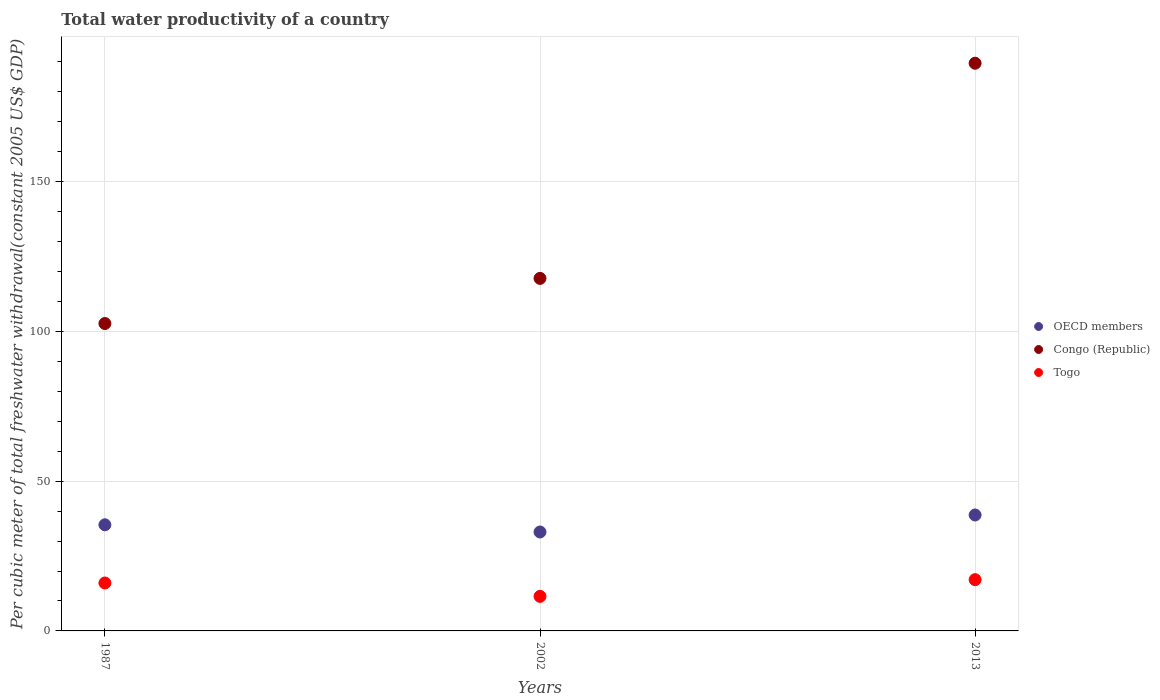What is the total water productivity in OECD members in 2002?
Provide a succinct answer. 33.04. Across all years, what is the maximum total water productivity in Togo?
Your answer should be compact. 17.12. Across all years, what is the minimum total water productivity in Congo (Republic)?
Make the answer very short. 102.65. In which year was the total water productivity in OECD members minimum?
Offer a terse response. 2002. What is the total total water productivity in OECD members in the graph?
Provide a short and direct response. 107.19. What is the difference between the total water productivity in Congo (Republic) in 1987 and that in 2002?
Make the answer very short. -15.07. What is the difference between the total water productivity in Togo in 2002 and the total water productivity in OECD members in 2013?
Your answer should be compact. -27.17. What is the average total water productivity in Congo (Republic) per year?
Your answer should be compact. 136.64. In the year 2013, what is the difference between the total water productivity in Congo (Republic) and total water productivity in OECD members?
Your answer should be compact. 150.85. In how many years, is the total water productivity in OECD members greater than 180 US$?
Provide a short and direct response. 0. What is the ratio of the total water productivity in OECD members in 2002 to that in 2013?
Make the answer very short. 0.85. Is the total water productivity in Togo in 1987 less than that in 2002?
Make the answer very short. No. What is the difference between the highest and the second highest total water productivity in OECD members?
Ensure brevity in your answer.  3.27. What is the difference between the highest and the lowest total water productivity in OECD members?
Your answer should be very brief. 5.68. In how many years, is the total water productivity in Congo (Republic) greater than the average total water productivity in Congo (Republic) taken over all years?
Ensure brevity in your answer.  1. Is the total water productivity in Togo strictly less than the total water productivity in Congo (Republic) over the years?
Ensure brevity in your answer.  Yes. How many dotlines are there?
Your answer should be very brief. 3. How many years are there in the graph?
Your answer should be very brief. 3. Are the values on the major ticks of Y-axis written in scientific E-notation?
Your answer should be very brief. No. Does the graph contain any zero values?
Your answer should be compact. No. Where does the legend appear in the graph?
Offer a terse response. Center right. How many legend labels are there?
Offer a terse response. 3. How are the legend labels stacked?
Offer a terse response. Vertical. What is the title of the graph?
Offer a very short reply. Total water productivity of a country. What is the label or title of the Y-axis?
Provide a short and direct response. Per cubic meter of total freshwater withdrawal(constant 2005 US$ GDP). What is the Per cubic meter of total freshwater withdrawal(constant 2005 US$ GDP) of OECD members in 1987?
Provide a short and direct response. 35.44. What is the Per cubic meter of total freshwater withdrawal(constant 2005 US$ GDP) of Congo (Republic) in 1987?
Your response must be concise. 102.65. What is the Per cubic meter of total freshwater withdrawal(constant 2005 US$ GDP) in Togo in 1987?
Your response must be concise. 16. What is the Per cubic meter of total freshwater withdrawal(constant 2005 US$ GDP) in OECD members in 2002?
Keep it short and to the point. 33.04. What is the Per cubic meter of total freshwater withdrawal(constant 2005 US$ GDP) of Congo (Republic) in 2002?
Provide a short and direct response. 117.72. What is the Per cubic meter of total freshwater withdrawal(constant 2005 US$ GDP) in Togo in 2002?
Provide a succinct answer. 11.54. What is the Per cubic meter of total freshwater withdrawal(constant 2005 US$ GDP) of OECD members in 2013?
Keep it short and to the point. 38.71. What is the Per cubic meter of total freshwater withdrawal(constant 2005 US$ GDP) in Congo (Republic) in 2013?
Your answer should be very brief. 189.56. What is the Per cubic meter of total freshwater withdrawal(constant 2005 US$ GDP) of Togo in 2013?
Provide a short and direct response. 17.12. Across all years, what is the maximum Per cubic meter of total freshwater withdrawal(constant 2005 US$ GDP) of OECD members?
Keep it short and to the point. 38.71. Across all years, what is the maximum Per cubic meter of total freshwater withdrawal(constant 2005 US$ GDP) of Congo (Republic)?
Your answer should be compact. 189.56. Across all years, what is the maximum Per cubic meter of total freshwater withdrawal(constant 2005 US$ GDP) of Togo?
Give a very brief answer. 17.12. Across all years, what is the minimum Per cubic meter of total freshwater withdrawal(constant 2005 US$ GDP) in OECD members?
Provide a succinct answer. 33.04. Across all years, what is the minimum Per cubic meter of total freshwater withdrawal(constant 2005 US$ GDP) in Congo (Republic)?
Offer a very short reply. 102.65. Across all years, what is the minimum Per cubic meter of total freshwater withdrawal(constant 2005 US$ GDP) of Togo?
Your answer should be compact. 11.54. What is the total Per cubic meter of total freshwater withdrawal(constant 2005 US$ GDP) of OECD members in the graph?
Offer a terse response. 107.19. What is the total Per cubic meter of total freshwater withdrawal(constant 2005 US$ GDP) of Congo (Republic) in the graph?
Give a very brief answer. 409.93. What is the total Per cubic meter of total freshwater withdrawal(constant 2005 US$ GDP) in Togo in the graph?
Your answer should be very brief. 44.66. What is the difference between the Per cubic meter of total freshwater withdrawal(constant 2005 US$ GDP) of OECD members in 1987 and that in 2002?
Offer a terse response. 2.4. What is the difference between the Per cubic meter of total freshwater withdrawal(constant 2005 US$ GDP) in Congo (Republic) in 1987 and that in 2002?
Give a very brief answer. -15.07. What is the difference between the Per cubic meter of total freshwater withdrawal(constant 2005 US$ GDP) in Togo in 1987 and that in 2002?
Provide a succinct answer. 4.46. What is the difference between the Per cubic meter of total freshwater withdrawal(constant 2005 US$ GDP) in OECD members in 1987 and that in 2013?
Your response must be concise. -3.27. What is the difference between the Per cubic meter of total freshwater withdrawal(constant 2005 US$ GDP) in Congo (Republic) in 1987 and that in 2013?
Keep it short and to the point. -86.91. What is the difference between the Per cubic meter of total freshwater withdrawal(constant 2005 US$ GDP) of Togo in 1987 and that in 2013?
Provide a short and direct response. -1.11. What is the difference between the Per cubic meter of total freshwater withdrawal(constant 2005 US$ GDP) of OECD members in 2002 and that in 2013?
Ensure brevity in your answer.  -5.68. What is the difference between the Per cubic meter of total freshwater withdrawal(constant 2005 US$ GDP) of Congo (Republic) in 2002 and that in 2013?
Give a very brief answer. -71.85. What is the difference between the Per cubic meter of total freshwater withdrawal(constant 2005 US$ GDP) of Togo in 2002 and that in 2013?
Your answer should be compact. -5.58. What is the difference between the Per cubic meter of total freshwater withdrawal(constant 2005 US$ GDP) of OECD members in 1987 and the Per cubic meter of total freshwater withdrawal(constant 2005 US$ GDP) of Congo (Republic) in 2002?
Make the answer very short. -82.28. What is the difference between the Per cubic meter of total freshwater withdrawal(constant 2005 US$ GDP) of OECD members in 1987 and the Per cubic meter of total freshwater withdrawal(constant 2005 US$ GDP) of Togo in 2002?
Your answer should be compact. 23.9. What is the difference between the Per cubic meter of total freshwater withdrawal(constant 2005 US$ GDP) in Congo (Republic) in 1987 and the Per cubic meter of total freshwater withdrawal(constant 2005 US$ GDP) in Togo in 2002?
Make the answer very short. 91.11. What is the difference between the Per cubic meter of total freshwater withdrawal(constant 2005 US$ GDP) in OECD members in 1987 and the Per cubic meter of total freshwater withdrawal(constant 2005 US$ GDP) in Congo (Republic) in 2013?
Give a very brief answer. -154.12. What is the difference between the Per cubic meter of total freshwater withdrawal(constant 2005 US$ GDP) in OECD members in 1987 and the Per cubic meter of total freshwater withdrawal(constant 2005 US$ GDP) in Togo in 2013?
Your answer should be very brief. 18.32. What is the difference between the Per cubic meter of total freshwater withdrawal(constant 2005 US$ GDP) in Congo (Republic) in 1987 and the Per cubic meter of total freshwater withdrawal(constant 2005 US$ GDP) in Togo in 2013?
Your answer should be very brief. 85.53. What is the difference between the Per cubic meter of total freshwater withdrawal(constant 2005 US$ GDP) in OECD members in 2002 and the Per cubic meter of total freshwater withdrawal(constant 2005 US$ GDP) in Congo (Republic) in 2013?
Offer a very short reply. -156.53. What is the difference between the Per cubic meter of total freshwater withdrawal(constant 2005 US$ GDP) in OECD members in 2002 and the Per cubic meter of total freshwater withdrawal(constant 2005 US$ GDP) in Togo in 2013?
Make the answer very short. 15.92. What is the difference between the Per cubic meter of total freshwater withdrawal(constant 2005 US$ GDP) in Congo (Republic) in 2002 and the Per cubic meter of total freshwater withdrawal(constant 2005 US$ GDP) in Togo in 2013?
Keep it short and to the point. 100.6. What is the average Per cubic meter of total freshwater withdrawal(constant 2005 US$ GDP) of OECD members per year?
Provide a succinct answer. 35.73. What is the average Per cubic meter of total freshwater withdrawal(constant 2005 US$ GDP) of Congo (Republic) per year?
Your answer should be compact. 136.64. What is the average Per cubic meter of total freshwater withdrawal(constant 2005 US$ GDP) of Togo per year?
Give a very brief answer. 14.89. In the year 1987, what is the difference between the Per cubic meter of total freshwater withdrawal(constant 2005 US$ GDP) of OECD members and Per cubic meter of total freshwater withdrawal(constant 2005 US$ GDP) of Congo (Republic)?
Your response must be concise. -67.21. In the year 1987, what is the difference between the Per cubic meter of total freshwater withdrawal(constant 2005 US$ GDP) in OECD members and Per cubic meter of total freshwater withdrawal(constant 2005 US$ GDP) in Togo?
Keep it short and to the point. 19.44. In the year 1987, what is the difference between the Per cubic meter of total freshwater withdrawal(constant 2005 US$ GDP) in Congo (Republic) and Per cubic meter of total freshwater withdrawal(constant 2005 US$ GDP) in Togo?
Keep it short and to the point. 86.65. In the year 2002, what is the difference between the Per cubic meter of total freshwater withdrawal(constant 2005 US$ GDP) in OECD members and Per cubic meter of total freshwater withdrawal(constant 2005 US$ GDP) in Congo (Republic)?
Give a very brief answer. -84.68. In the year 2002, what is the difference between the Per cubic meter of total freshwater withdrawal(constant 2005 US$ GDP) of OECD members and Per cubic meter of total freshwater withdrawal(constant 2005 US$ GDP) of Togo?
Your answer should be very brief. 21.5. In the year 2002, what is the difference between the Per cubic meter of total freshwater withdrawal(constant 2005 US$ GDP) of Congo (Republic) and Per cubic meter of total freshwater withdrawal(constant 2005 US$ GDP) of Togo?
Provide a short and direct response. 106.18. In the year 2013, what is the difference between the Per cubic meter of total freshwater withdrawal(constant 2005 US$ GDP) of OECD members and Per cubic meter of total freshwater withdrawal(constant 2005 US$ GDP) of Congo (Republic)?
Offer a terse response. -150.85. In the year 2013, what is the difference between the Per cubic meter of total freshwater withdrawal(constant 2005 US$ GDP) in OECD members and Per cubic meter of total freshwater withdrawal(constant 2005 US$ GDP) in Togo?
Make the answer very short. 21.59. In the year 2013, what is the difference between the Per cubic meter of total freshwater withdrawal(constant 2005 US$ GDP) of Congo (Republic) and Per cubic meter of total freshwater withdrawal(constant 2005 US$ GDP) of Togo?
Provide a succinct answer. 172.45. What is the ratio of the Per cubic meter of total freshwater withdrawal(constant 2005 US$ GDP) in OECD members in 1987 to that in 2002?
Your response must be concise. 1.07. What is the ratio of the Per cubic meter of total freshwater withdrawal(constant 2005 US$ GDP) of Congo (Republic) in 1987 to that in 2002?
Ensure brevity in your answer.  0.87. What is the ratio of the Per cubic meter of total freshwater withdrawal(constant 2005 US$ GDP) of Togo in 1987 to that in 2002?
Provide a succinct answer. 1.39. What is the ratio of the Per cubic meter of total freshwater withdrawal(constant 2005 US$ GDP) of OECD members in 1987 to that in 2013?
Provide a succinct answer. 0.92. What is the ratio of the Per cubic meter of total freshwater withdrawal(constant 2005 US$ GDP) in Congo (Republic) in 1987 to that in 2013?
Provide a short and direct response. 0.54. What is the ratio of the Per cubic meter of total freshwater withdrawal(constant 2005 US$ GDP) in Togo in 1987 to that in 2013?
Your answer should be compact. 0.93. What is the ratio of the Per cubic meter of total freshwater withdrawal(constant 2005 US$ GDP) of OECD members in 2002 to that in 2013?
Your answer should be very brief. 0.85. What is the ratio of the Per cubic meter of total freshwater withdrawal(constant 2005 US$ GDP) in Congo (Republic) in 2002 to that in 2013?
Offer a terse response. 0.62. What is the ratio of the Per cubic meter of total freshwater withdrawal(constant 2005 US$ GDP) in Togo in 2002 to that in 2013?
Your answer should be very brief. 0.67. What is the difference between the highest and the second highest Per cubic meter of total freshwater withdrawal(constant 2005 US$ GDP) in OECD members?
Offer a very short reply. 3.27. What is the difference between the highest and the second highest Per cubic meter of total freshwater withdrawal(constant 2005 US$ GDP) of Congo (Republic)?
Your answer should be very brief. 71.85. What is the difference between the highest and the second highest Per cubic meter of total freshwater withdrawal(constant 2005 US$ GDP) in Togo?
Your answer should be compact. 1.11. What is the difference between the highest and the lowest Per cubic meter of total freshwater withdrawal(constant 2005 US$ GDP) in OECD members?
Make the answer very short. 5.68. What is the difference between the highest and the lowest Per cubic meter of total freshwater withdrawal(constant 2005 US$ GDP) of Congo (Republic)?
Ensure brevity in your answer.  86.91. What is the difference between the highest and the lowest Per cubic meter of total freshwater withdrawal(constant 2005 US$ GDP) in Togo?
Your answer should be compact. 5.58. 